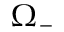<formula> <loc_0><loc_0><loc_500><loc_500>\Omega _ { - }</formula> 